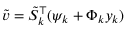<formula> <loc_0><loc_0><loc_500><loc_500>\tilde { v } = \tilde { S } _ { k } ^ { \top } ( \psi _ { k } + \Phi _ { k } y _ { k } )</formula> 